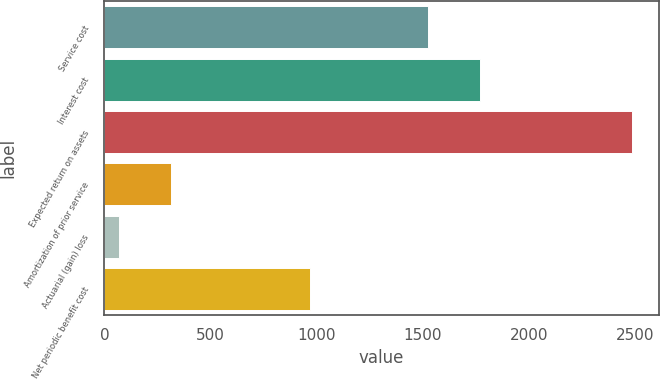Convert chart to OTSL. <chart><loc_0><loc_0><loc_500><loc_500><bar_chart><fcel>Service cost<fcel>Interest cost<fcel>Expected return on assets<fcel>Amortization of prior service<fcel>Actuarial (gain) loss<fcel>Net periodic benefit cost<nl><fcel>1527<fcel>1768.9<fcel>2489<fcel>311.9<fcel>70<fcel>970<nl></chart> 